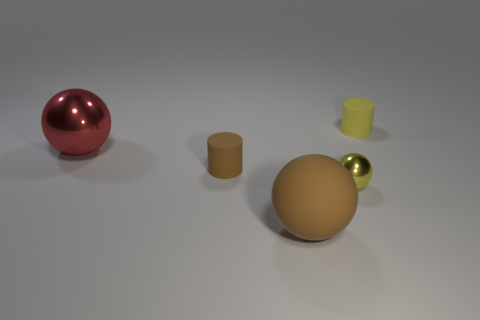Subtract all tiny yellow metal balls. How many balls are left? 2 Subtract all yellow balls. How many balls are left? 2 Subtract all balls. How many objects are left? 2 Subtract 2 balls. How many balls are left? 1 Add 2 spheres. How many objects exist? 7 Add 1 big brown objects. How many big brown objects are left? 2 Add 4 tiny yellow cylinders. How many tiny yellow cylinders exist? 5 Subtract 0 blue spheres. How many objects are left? 5 Subtract all green balls. Subtract all cyan blocks. How many balls are left? 3 Subtract all cyan spheres. How many yellow cylinders are left? 1 